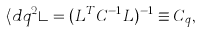Convert formula to latex. <formula><loc_0><loc_0><loc_500><loc_500>\langle d q ^ { 2 } \rangle = ( L ^ { T } C ^ { - 1 } L ) ^ { - 1 } \equiv C _ { q } ,</formula> 